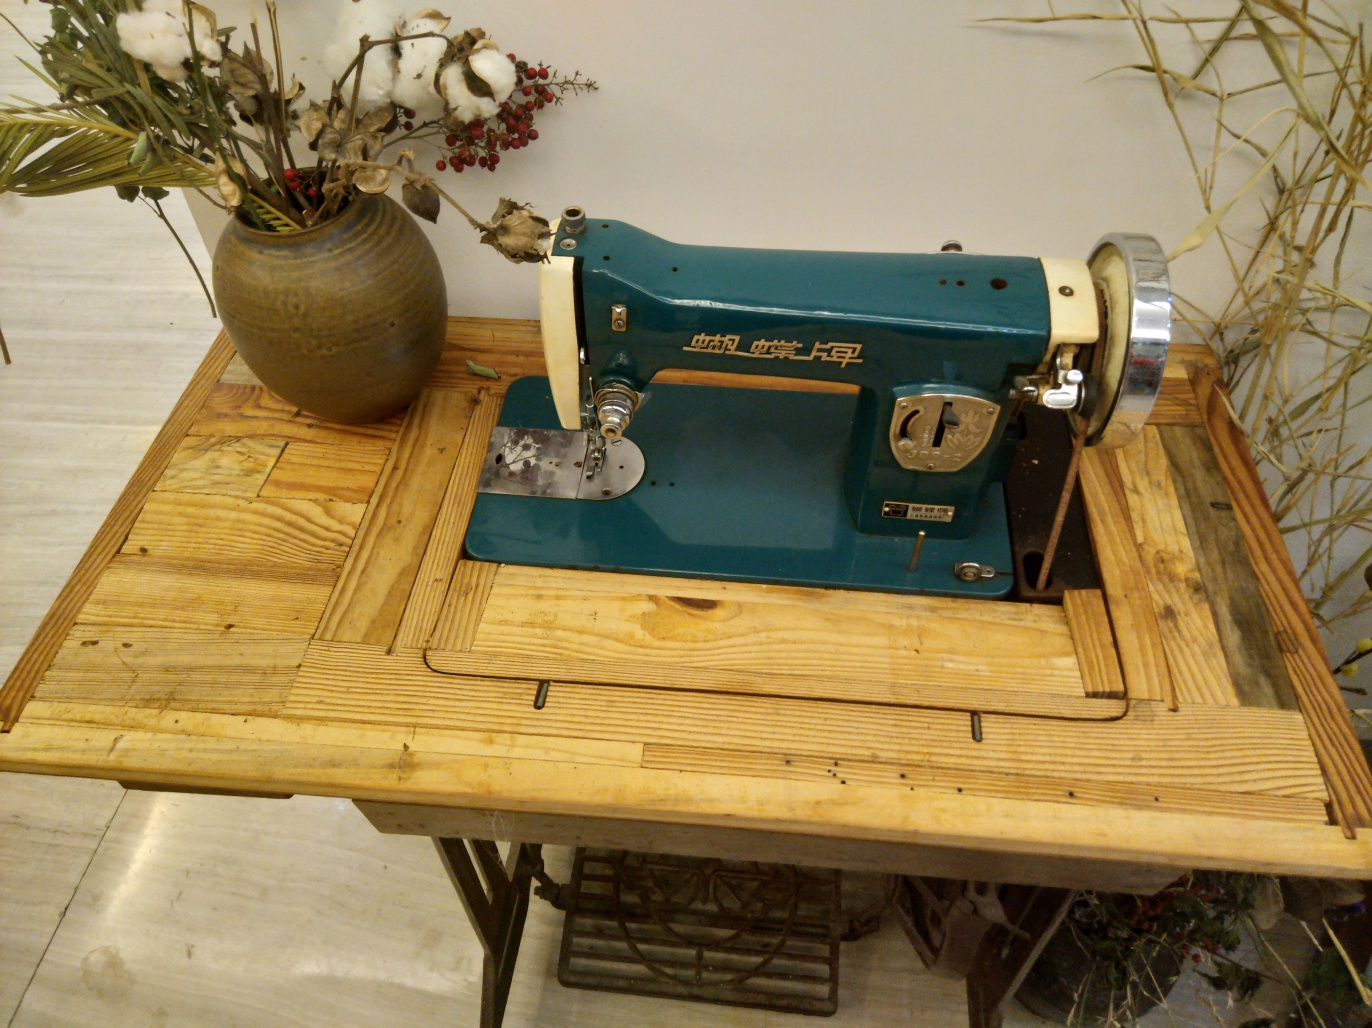What can the items in the background tell us about the possible setting or use of this space? The items in the background, including the potted cotton and bamboo stalks, suggest a penchant for organic and raw materials, which could imply that this space belongs to someone with an interest in textile arts or natural decor. It may serve as a creative workshop or a cozy corner in a home dedicated to crafts and handiwork. 